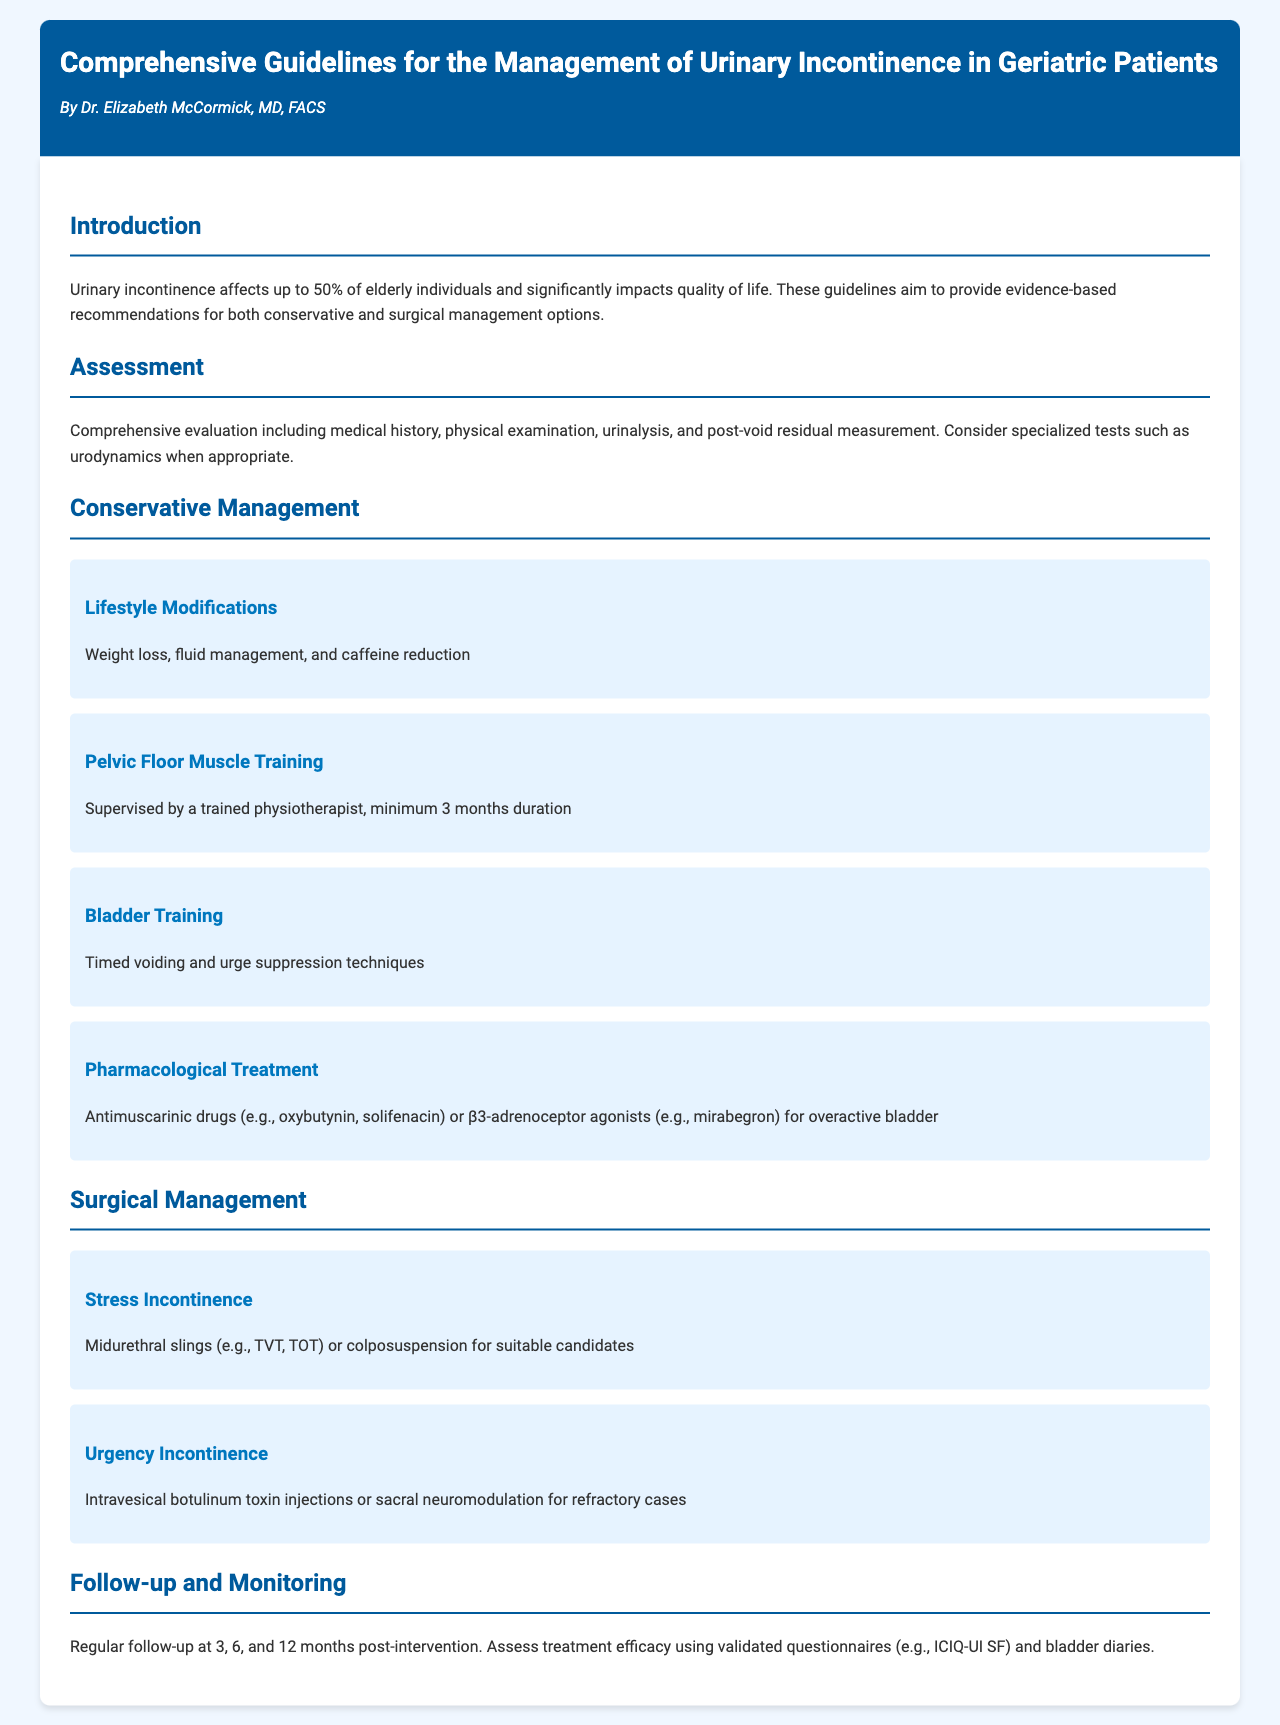what percentage of elderly individuals are affected by urinary incontinence? The document states that urinary incontinence affects up to 50% of elderly individuals.
Answer: 50% what is the minimum duration for pelvic floor muscle training? The guidelines specify a minimum duration of 3 months for pelvic floor muscle training supervised by a trained physiotherapist.
Answer: 3 months which pharmacological treatment is recommended for overactive bladder? The document recommends antimuscarinic drugs such as oxybutynin or solifenacin for managing overactive bladder.
Answer: antimuscarinic drugs what surgical option is suggested for stress incontinence? The document suggests midurethral slings or colposuspension for suitable candidates with stress incontinence.
Answer: midurethral slings how often should follow-up assessments be conducted post-intervention? The guidelines recommend regular follow-up assessments at 3, 6, and 12 months post-intervention.
Answer: 3, 6, and 12 months what type of monitoring tool is mentioned for assessing treatment efficacy? The document mentions using validated questionnaires such as ICIQ-UI SF to assess treatment efficacy.
Answer: ICIQ-UI SF what is the name of the author of the guidelines? The guidelines are authored by Dr. Elizabeth McCormick, MD, FACS.
Answer: Dr. Elizabeth McCormick which type of incontinence is treated with intravesical botulinum toxin injections? The document states that intravesical botulinum toxin injections are used for treating urgency incontinence in refractory cases.
Answer: urgency incontinence 